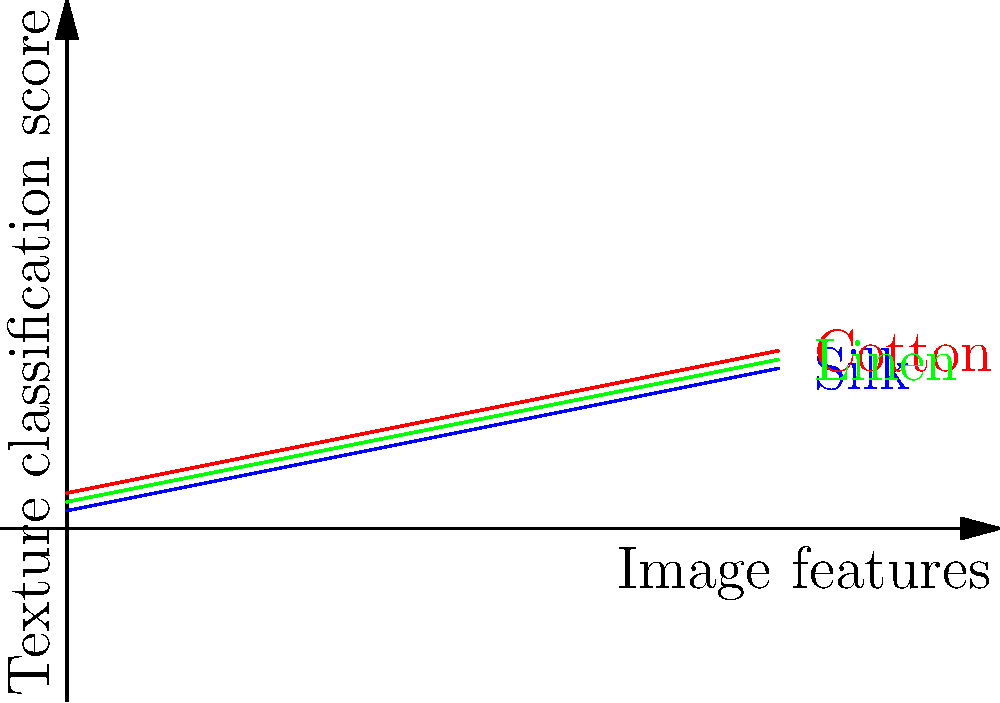Based on the graph showing texture classification scores for different fabric types, which fabric consistently exhibits the highest classification score across all image feature levels? To determine which fabric consistently exhibits the highest classification score, we need to analyze the graph step-by-step:

1. The graph shows three lines representing different fabric types: blue for Silk, red for Cotton, and green for Linen.

2. The x-axis represents "Image features," while the y-axis represents "Texture classification score."

3. We need to compare the position of each line relative to the others across all x-axis values:

   - At x = 0: Cotton (red) is highest
   - At x = 1: Cotton (red) is highest
   - At x = 2: Cotton (red) is highest
   - At x = 3: Cotton (red) is highest
   - At x = 4: Cotton (red) is highest

4. We can observe that the red line (Cotton) consistently remains above the blue (Silk) and green (Linen) lines throughout the entire range of image features.

5. This indicates that Cotton consistently achieves the highest texture classification score across all image feature levels.

Therefore, based on the graph, Cotton is the fabric that consistently exhibits the highest classification score across all image feature levels.
Answer: Cotton 